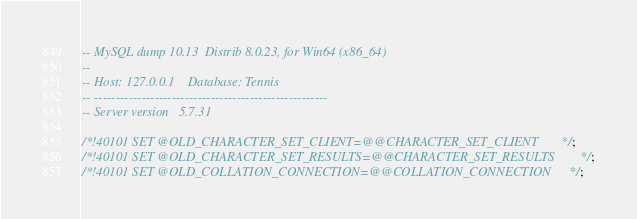<code> <loc_0><loc_0><loc_500><loc_500><_SQL_>-- MySQL dump 10.13  Distrib 8.0.23, for Win64 (x86_64)
--
-- Host: 127.0.0.1    Database: Tennis
-- ------------------------------------------------------
-- Server version	5.7.31

/*!40101 SET @OLD_CHARACTER_SET_CLIENT=@@CHARACTER_SET_CLIENT */;
/*!40101 SET @OLD_CHARACTER_SET_RESULTS=@@CHARACTER_SET_RESULTS */;
/*!40101 SET @OLD_COLLATION_CONNECTION=@@COLLATION_CONNECTION */;</code> 